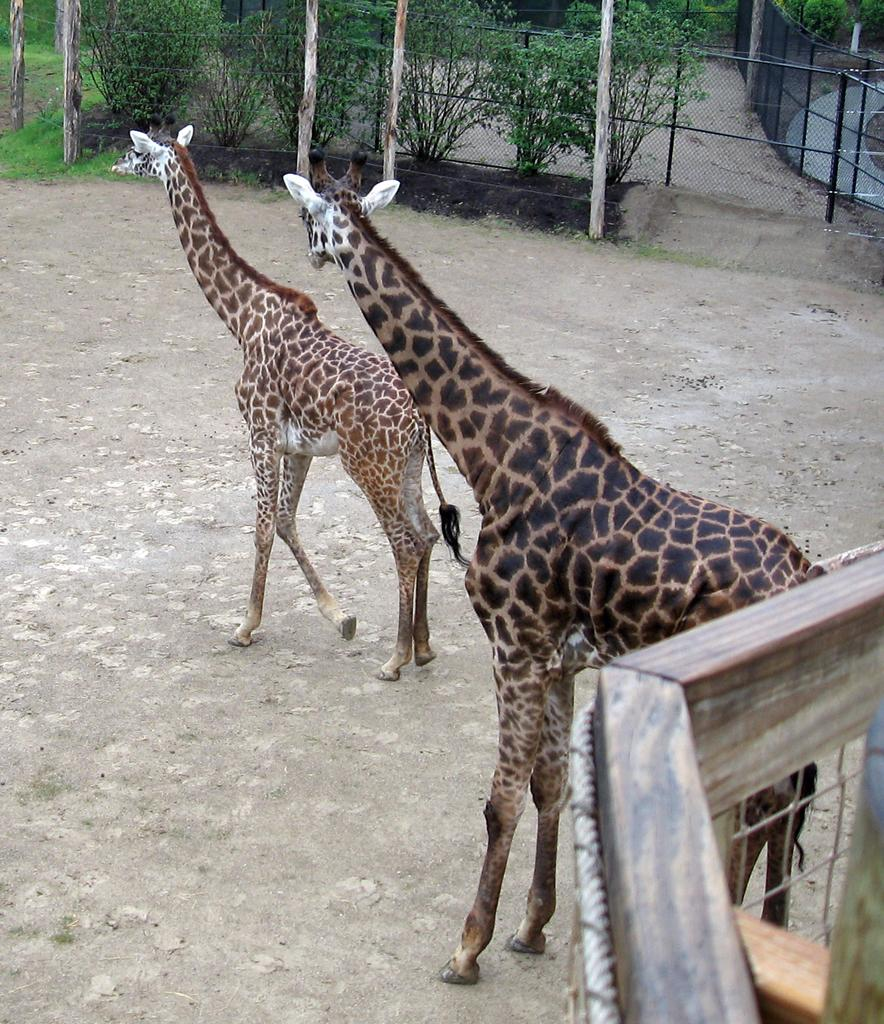How many giraffes are in the image? There are two giraffes in the image. Where are the giraffes standing? The giraffes are standing on a path. What can be seen running along the length of the image? There is fencing visible from left to right in the image. What is visible in the background of the image? There are poles and trees in the background of the image. What type of milk is being served during recess in the image? There is no recess or milk present in the image; it features two giraffes standing on a path with fencing and poles in the background. Can you spot a scarecrow in the image? There is no scarecrow present in the image. 